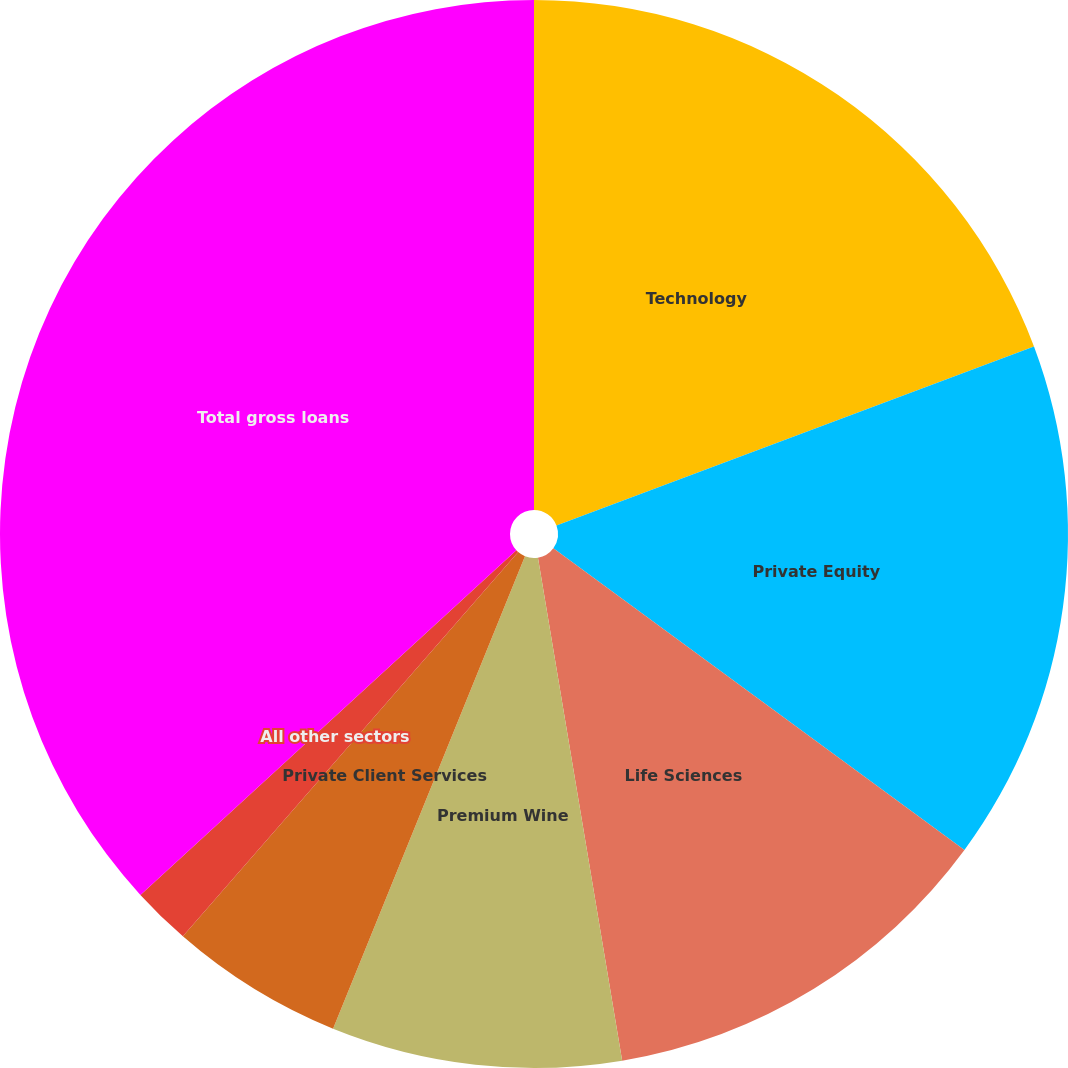Convert chart. <chart><loc_0><loc_0><loc_500><loc_500><pie_chart><fcel>Technology<fcel>Private Equity<fcel>Life Sciences<fcel>Premium Wine<fcel>Private Client Services<fcel>All other sectors<fcel>Total gross loans<nl><fcel>19.29%<fcel>15.79%<fcel>12.28%<fcel>8.78%<fcel>5.28%<fcel>1.77%<fcel>36.81%<nl></chart> 